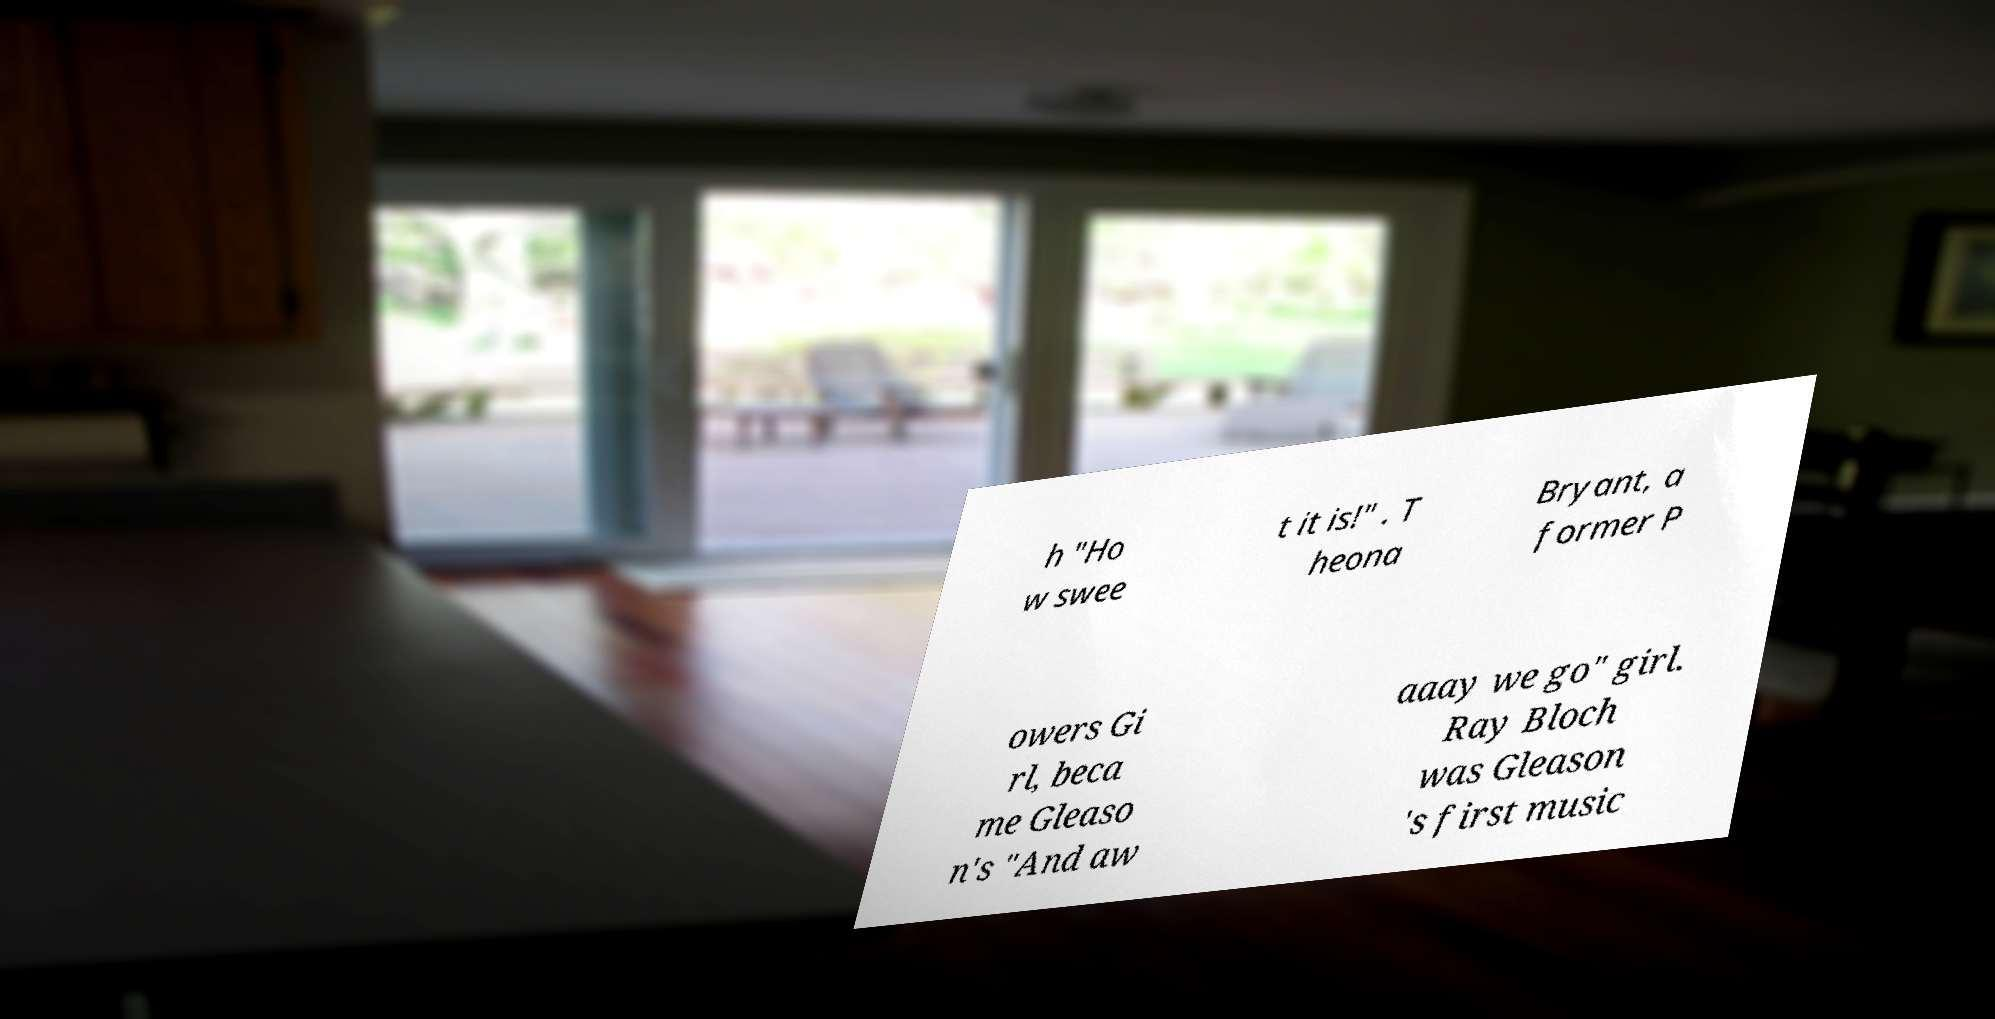I need the written content from this picture converted into text. Can you do that? h "Ho w swee t it is!" . T heona Bryant, a former P owers Gi rl, beca me Gleaso n's "And aw aaay we go" girl. Ray Bloch was Gleason 's first music 